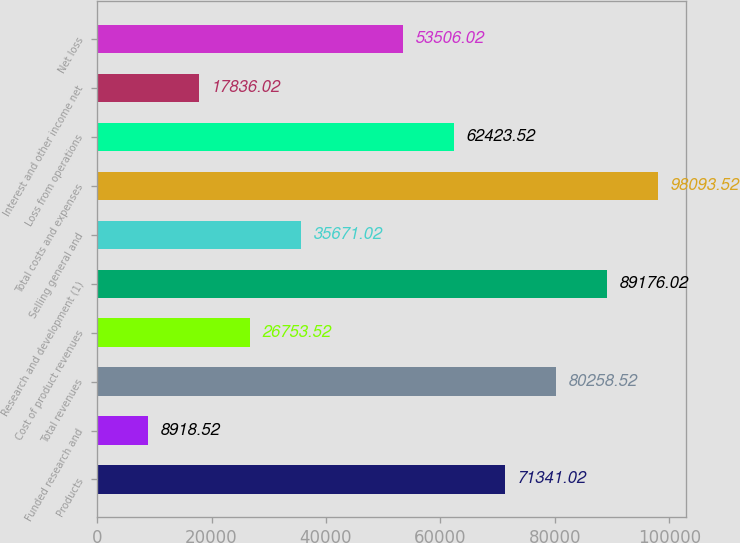Convert chart. <chart><loc_0><loc_0><loc_500><loc_500><bar_chart><fcel>Products<fcel>Funded research and<fcel>Total revenues<fcel>Cost of product revenues<fcel>Research and development (1)<fcel>Selling general and<fcel>Total costs and expenses<fcel>Loss from operations<fcel>Interest and other income net<fcel>Net loss<nl><fcel>71341<fcel>8918.52<fcel>80258.5<fcel>26753.5<fcel>89176<fcel>35671<fcel>98093.5<fcel>62423.5<fcel>17836<fcel>53506<nl></chart> 